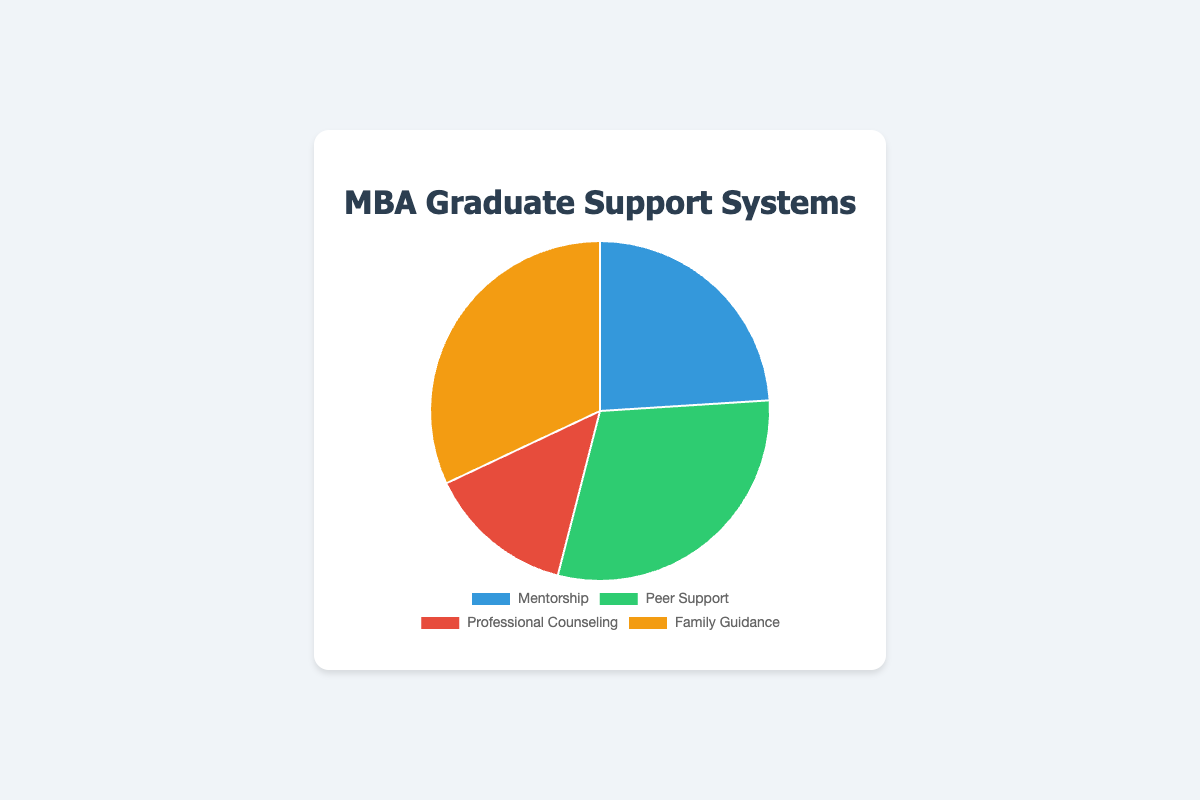What type of support system is utilized the most by MBA graduates? By looking at the pie chart, we can see the sizes of the different segments. The "Family Guidance" segment is the largest, indicating it is utilized the most.
Answer: Family Guidance Which support system is utilized less, Professional Counseling or Mentorship? We compare the sizes of the respective segments for "Professional Counseling" and "Mentorship". The "Professional Counseling" segment is smaller than the "Mentorship" segment.
Answer: Professional Counseling What is the combined percentage for Peer Support and Professional Counseling? Adding the percentages for Peer Support (75%) and Professional Counseling (35%) gives us: 75% + 35% = 110%.
Answer: 110% How much larger is the utilization of Family Guidance compared to Peer Support? Subtract the percentage for Peer Support (75%) from the percentage for Family Guidance (80%): 80% - 75% = 5%.
Answer: 5% Which support system is represented by the green segment in the chart? By referring to the colors of the segments, the green segment represents "Peer Support".
Answer: Peer Support Is Mentorship utilized more or less than 50% of the time by MBA graduates? The percentage for Mentorship is 60%, which is greater than 50%.
Answer: More What is the smallest segment in the pie chart and its percentage? By observing the sizes of the segments, the smallest segment is "Professional Counseling" with a percentage of 35%.
Answer: Professional Counseling (35%) How much less is the usage of Professional Counseling compared to Family Guidance? Subtract the percentage for Professional Counseling (35%) from the percentage for Family Guidance (80%): 80% - 35% = 45%.
Answer: 45% What support systems combine to precisely make up half of the total support systems utilized? Adding percentages for Mentorship (60%) and Professional Counseling (35%) does not equal 50%. However, Peer Support (75%) and Professional Counseling (35%) equal 110%, which does not equal 50%. The closest combination is not exact, so no exact sum of 50% is observed.
Answer: None What is the second highest utilized support system? The largest segment is Family Guidance (80%), and the next largest is Peer Support (75%).
Answer: Peer Support 